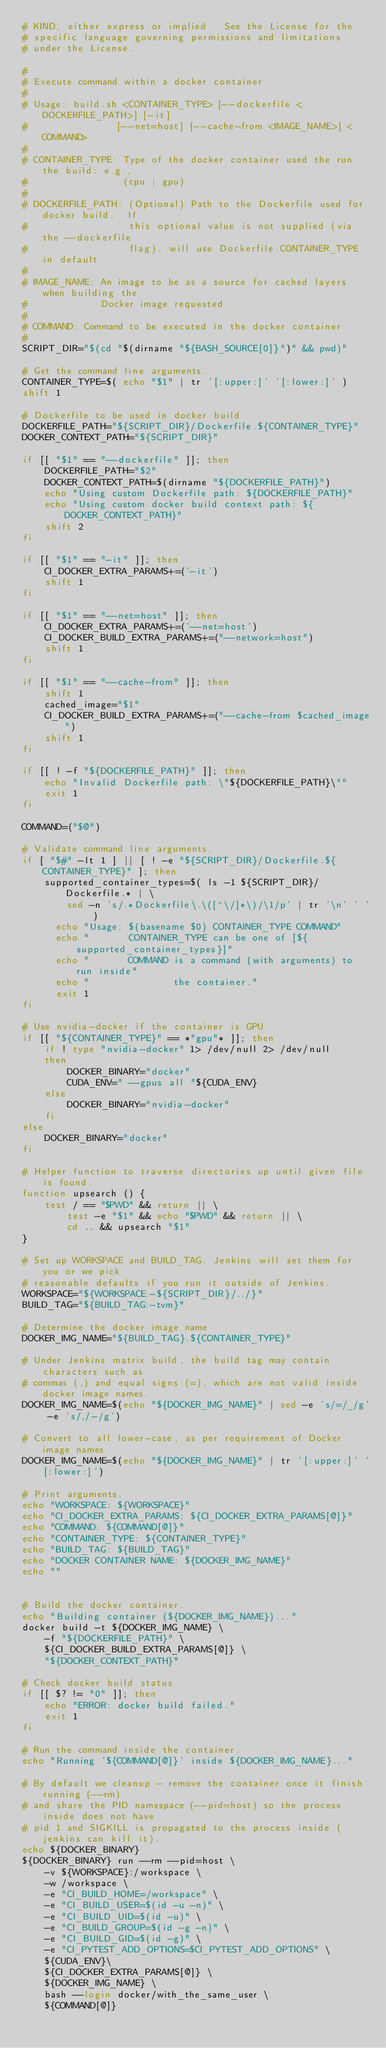<code> <loc_0><loc_0><loc_500><loc_500><_Bash_># KIND, either express or implied.  See the License for the
# specific language governing permissions and limitations
# under the License.

#
# Execute command within a docker container
#
# Usage: build.sh <CONTAINER_TYPE> [--dockerfile <DOCKERFILE_PATH>] [-it]
#                [--net=host] [--cache-from <IMAGE_NAME>] <COMMAND>
#
# CONTAINER_TYPE: Type of the docker container used the run the build: e.g.,
#                 (cpu | gpu)
#
# DOCKERFILE_PATH: (Optional) Path to the Dockerfile used for docker build.  If
#                  this optional value is not supplied (via the --dockerfile
#                  flag), will use Dockerfile.CONTAINER_TYPE in default
#
# IMAGE_NAME: An image to be as a source for cached layers when building the
#             Docker image requested.
#
# COMMAND: Command to be executed in the docker container
#
SCRIPT_DIR="$(cd "$(dirname "${BASH_SOURCE[0]}")" && pwd)"

# Get the command line arguments.
CONTAINER_TYPE=$( echo "$1" | tr '[:upper:]' '[:lower:]' )
shift 1

# Dockerfile to be used in docker build
DOCKERFILE_PATH="${SCRIPT_DIR}/Dockerfile.${CONTAINER_TYPE}"
DOCKER_CONTEXT_PATH="${SCRIPT_DIR}"

if [[ "$1" == "--dockerfile" ]]; then
    DOCKERFILE_PATH="$2"
    DOCKER_CONTEXT_PATH=$(dirname "${DOCKERFILE_PATH}")
    echo "Using custom Dockerfile path: ${DOCKERFILE_PATH}"
    echo "Using custom docker build context path: ${DOCKER_CONTEXT_PATH}"
    shift 2
fi

if [[ "$1" == "-it" ]]; then
    CI_DOCKER_EXTRA_PARAMS+=('-it')
    shift 1
fi

if [[ "$1" == "--net=host" ]]; then
    CI_DOCKER_EXTRA_PARAMS+=('--net=host')
    CI_DOCKER_BUILD_EXTRA_PARAMS+=("--network=host")
    shift 1
fi

if [[ "$1" == "--cache-from" ]]; then
    shift 1
    cached_image="$1"
    CI_DOCKER_BUILD_EXTRA_PARAMS+=("--cache-from $cached_image")
    shift 1
fi

if [[ ! -f "${DOCKERFILE_PATH}" ]]; then
    echo "Invalid Dockerfile path: \"${DOCKERFILE_PATH}\""
    exit 1
fi

COMMAND=("$@")

# Validate command line arguments.
if [ "$#" -lt 1 ] || [ ! -e "${SCRIPT_DIR}/Dockerfile.${CONTAINER_TYPE}" ]; then
    supported_container_types=$( ls -1 ${SCRIPT_DIR}/Dockerfile.* | \
        sed -n 's/.*Dockerfile\.\([^\/]*\)/\1/p' | tr '\n' ' ' )
      echo "Usage: $(basename $0) CONTAINER_TYPE COMMAND"
      echo "       CONTAINER_TYPE can be one of [${supported_container_types}]"
      echo "       COMMAND is a command (with arguments) to run inside"
      echo "               the container."
      exit 1
fi

# Use nvidia-docker if the container is GPU.
if [[ "${CONTAINER_TYPE}" == *"gpu"* ]]; then
    if ! type "nvidia-docker" 1> /dev/null 2> /dev/null
    then
        DOCKER_BINARY="docker"
        CUDA_ENV=" --gpus all "${CUDA_ENV}
    else
        DOCKER_BINARY="nvidia-docker"
    fi
else
    DOCKER_BINARY="docker"
fi

# Helper function to traverse directories up until given file is found.
function upsearch () {
    test / == "$PWD" && return || \
        test -e "$1" && echo "$PWD" && return || \
        cd .. && upsearch "$1"
}

# Set up WORKSPACE and BUILD_TAG. Jenkins will set them for you or we pick
# reasonable defaults if you run it outside of Jenkins.
WORKSPACE="${WORKSPACE:-${SCRIPT_DIR}/../}"
BUILD_TAG="${BUILD_TAG:-tvm}"

# Determine the docker image name
DOCKER_IMG_NAME="${BUILD_TAG}.${CONTAINER_TYPE}"

# Under Jenkins matrix build, the build tag may contain characters such as
# commas (,) and equal signs (=), which are not valid inside docker image names.
DOCKER_IMG_NAME=$(echo "${DOCKER_IMG_NAME}" | sed -e 's/=/_/g' -e 's/,/-/g')

# Convert to all lower-case, as per requirement of Docker image names
DOCKER_IMG_NAME=$(echo "${DOCKER_IMG_NAME}" | tr '[:upper:]' '[:lower:]')

# Print arguments.
echo "WORKSPACE: ${WORKSPACE}"
echo "CI_DOCKER_EXTRA_PARAMS: ${CI_DOCKER_EXTRA_PARAMS[@]}"
echo "COMMAND: ${COMMAND[@]}"
echo "CONTAINER_TYPE: ${CONTAINER_TYPE}"
echo "BUILD_TAG: ${BUILD_TAG}"
echo "DOCKER CONTAINER NAME: ${DOCKER_IMG_NAME}"
echo ""


# Build the docker container.
echo "Building container (${DOCKER_IMG_NAME})..."
docker build -t ${DOCKER_IMG_NAME} \
    -f "${DOCKERFILE_PATH}" \
    ${CI_DOCKER_BUILD_EXTRA_PARAMS[@]} \
    "${DOCKER_CONTEXT_PATH}"

# Check docker build status
if [[ $? != "0" ]]; then
    echo "ERROR: docker build failed."
    exit 1
fi

# Run the command inside the container.
echo "Running '${COMMAND[@]}' inside ${DOCKER_IMG_NAME}..."

# By default we cleanup - remove the container once it finish running (--rm)
# and share the PID namespace (--pid=host) so the process inside does not have
# pid 1 and SIGKILL is propagated to the process inside (jenkins can kill it).
echo ${DOCKER_BINARY}
${DOCKER_BINARY} run --rm --pid=host \
    -v ${WORKSPACE}:/workspace \
    -w /workspace \
    -e "CI_BUILD_HOME=/workspace" \
    -e "CI_BUILD_USER=$(id -u -n)" \
    -e "CI_BUILD_UID=$(id -u)" \
    -e "CI_BUILD_GROUP=$(id -g -n)" \
    -e "CI_BUILD_GID=$(id -g)" \
    -e "CI_PYTEST_ADD_OPTIONS=$CI_PYTEST_ADD_OPTIONS" \
    ${CUDA_ENV}\
    ${CI_DOCKER_EXTRA_PARAMS[@]} \
    ${DOCKER_IMG_NAME} \
    bash --login docker/with_the_same_user \
    ${COMMAND[@]}
</code> 